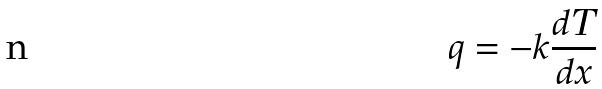<formula> <loc_0><loc_0><loc_500><loc_500>q = - k \frac { d T } { d x }</formula> 